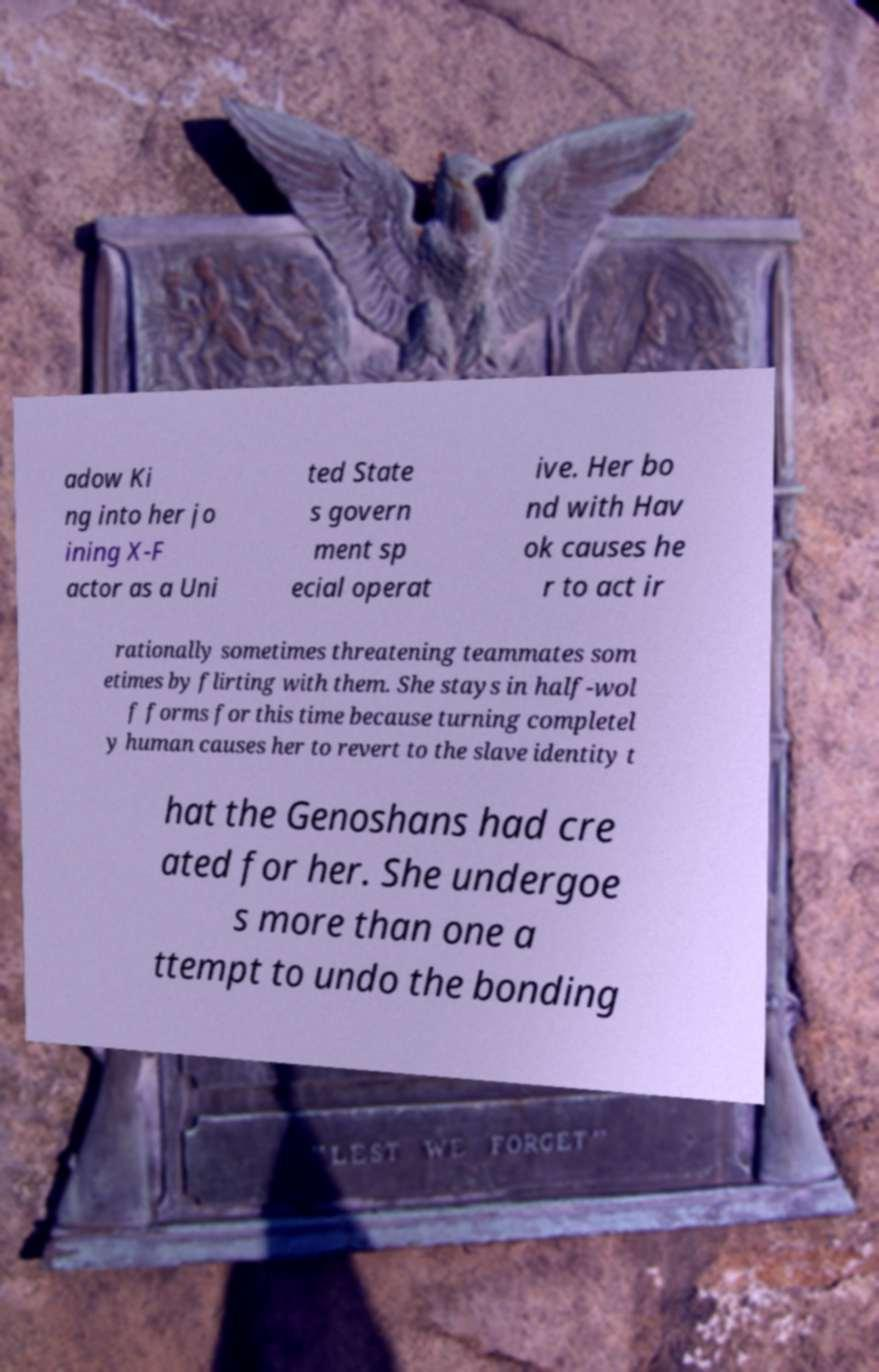Can you read and provide the text displayed in the image?This photo seems to have some interesting text. Can you extract and type it out for me? adow Ki ng into her jo ining X-F actor as a Uni ted State s govern ment sp ecial operat ive. Her bo nd with Hav ok causes he r to act ir rationally sometimes threatening teammates som etimes by flirting with them. She stays in half-wol f forms for this time because turning completel y human causes her to revert to the slave identity t hat the Genoshans had cre ated for her. She undergoe s more than one a ttempt to undo the bonding 